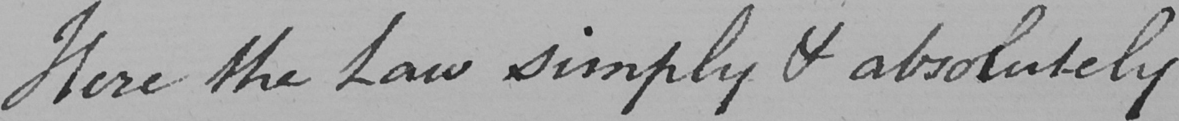Please transcribe the handwritten text in this image. Here the Law simply & absolutely 